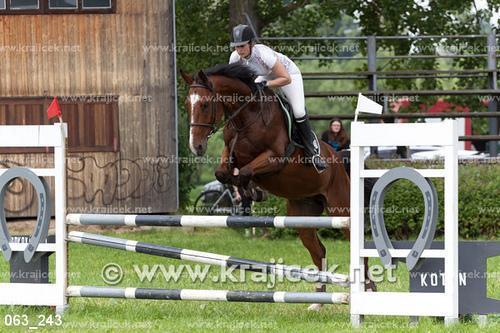How many horses?
Give a very brief answer. 1. 